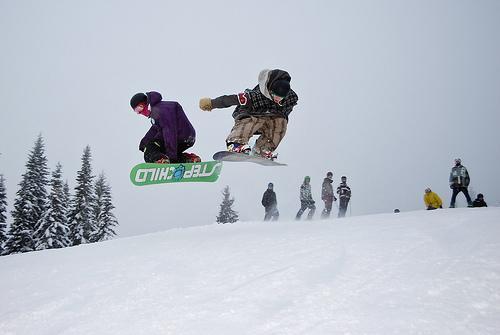How many people are in the air?
Give a very brief answer. 2. 